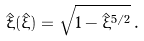Convert formula to latex. <formula><loc_0><loc_0><loc_500><loc_500>\dot { \hat { \xi } } ( \hat { \xi } ) = \sqrt { 1 - \hat { \xi } ^ { 5 / 2 } } \, .</formula> 